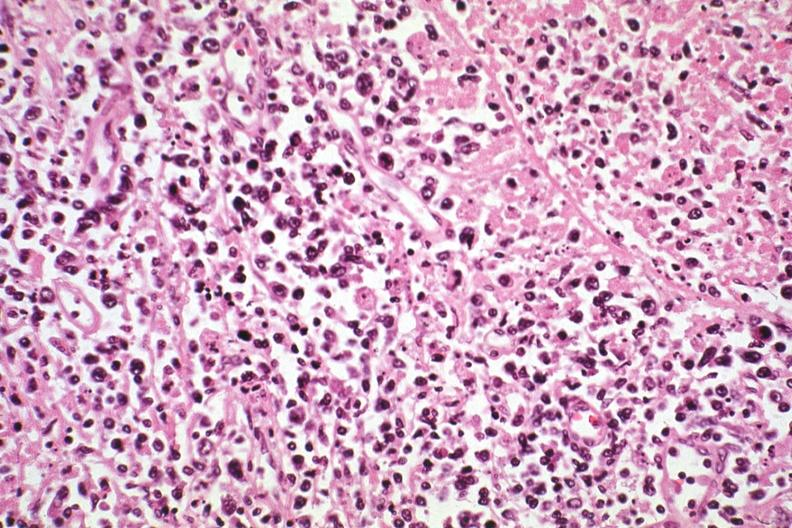what is present?
Answer the question using a single word or phrase. Lymph node 